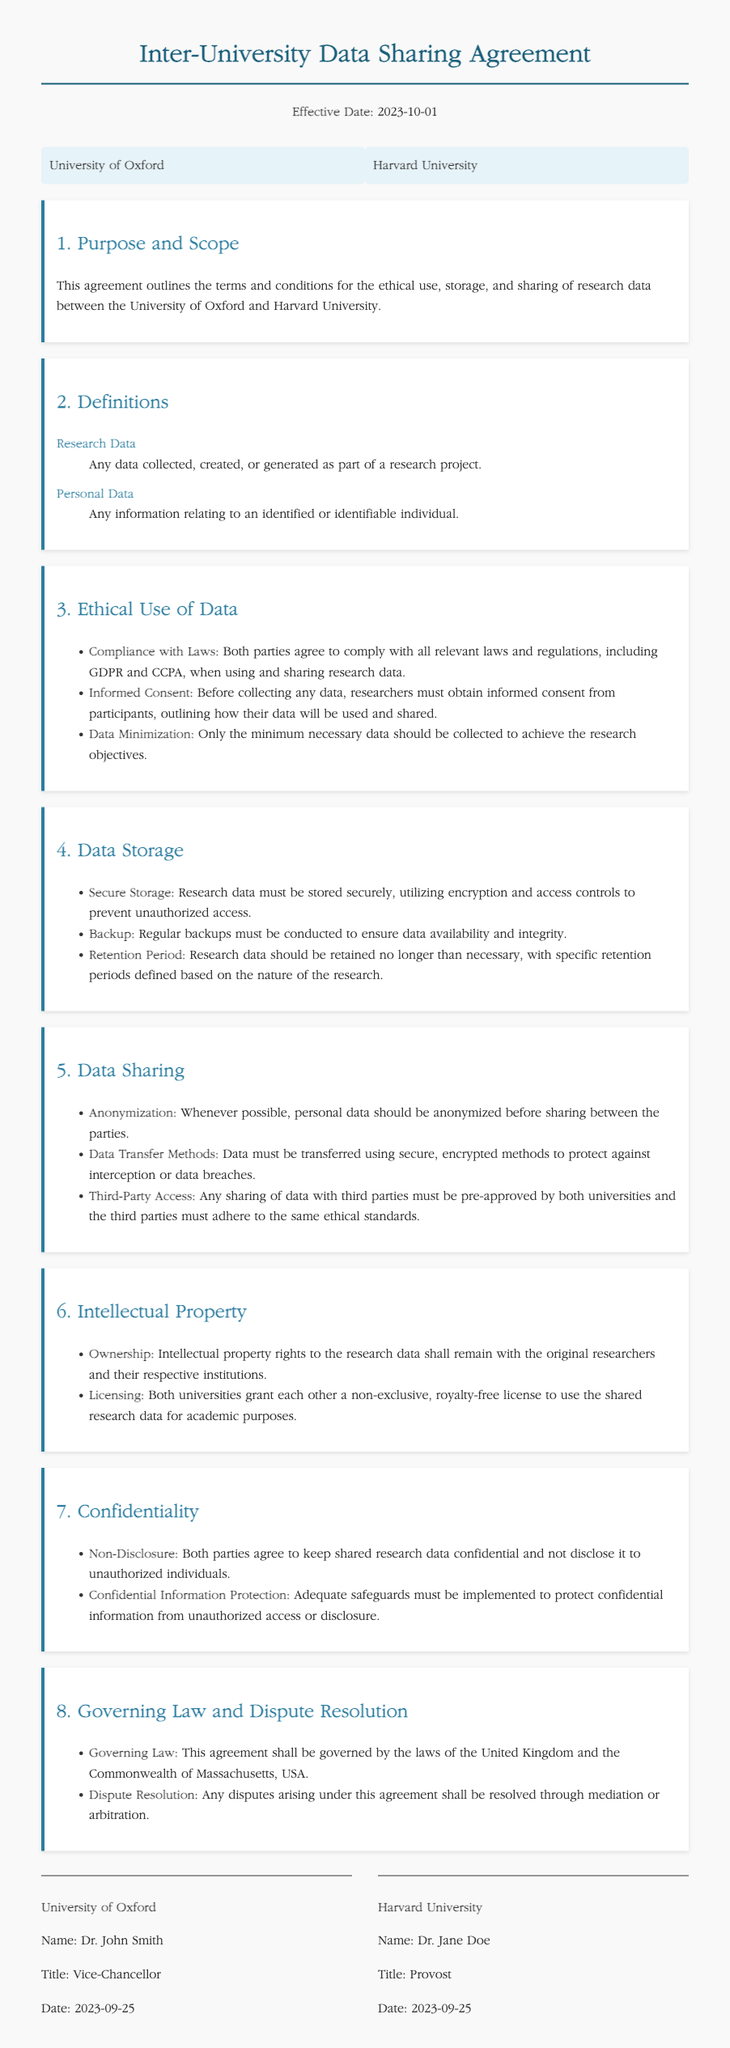What is the effective date of the agreement? The effective date is clearly stated in the header of the document.
Answer: 2023-10-01 Who are the parties involved in this agreement? The document identifies the institutions that are entering the agreement.
Answer: University of Oxford and Harvard University What must researchers obtain before collecting data? This is outlined under the Ethical Use of Data section.
Answer: Informed consent What is the purpose of this agreement? The purpose is mentioned in the first section of the document.
Answer: Ethical use, storage, and sharing of research data What governs this agreement? The relevant laws applicable to this agreement are mentioned in the governing law section.
Answer: Laws of the United Kingdom and the Commonwealth of Massachusetts, USA What must be done to protect shared research data? The agreement outlines requirements for the protection of research data.
Answer: Keep data confidential What type of license is granted to use shared research data? The document specifies the type of licensing for the use of research data.
Answer: Non-exclusive, royalty-free license What methods should be used for data transfer? The document emphasizes secure practices for data sharing.
Answer: Secure, encrypted methods 